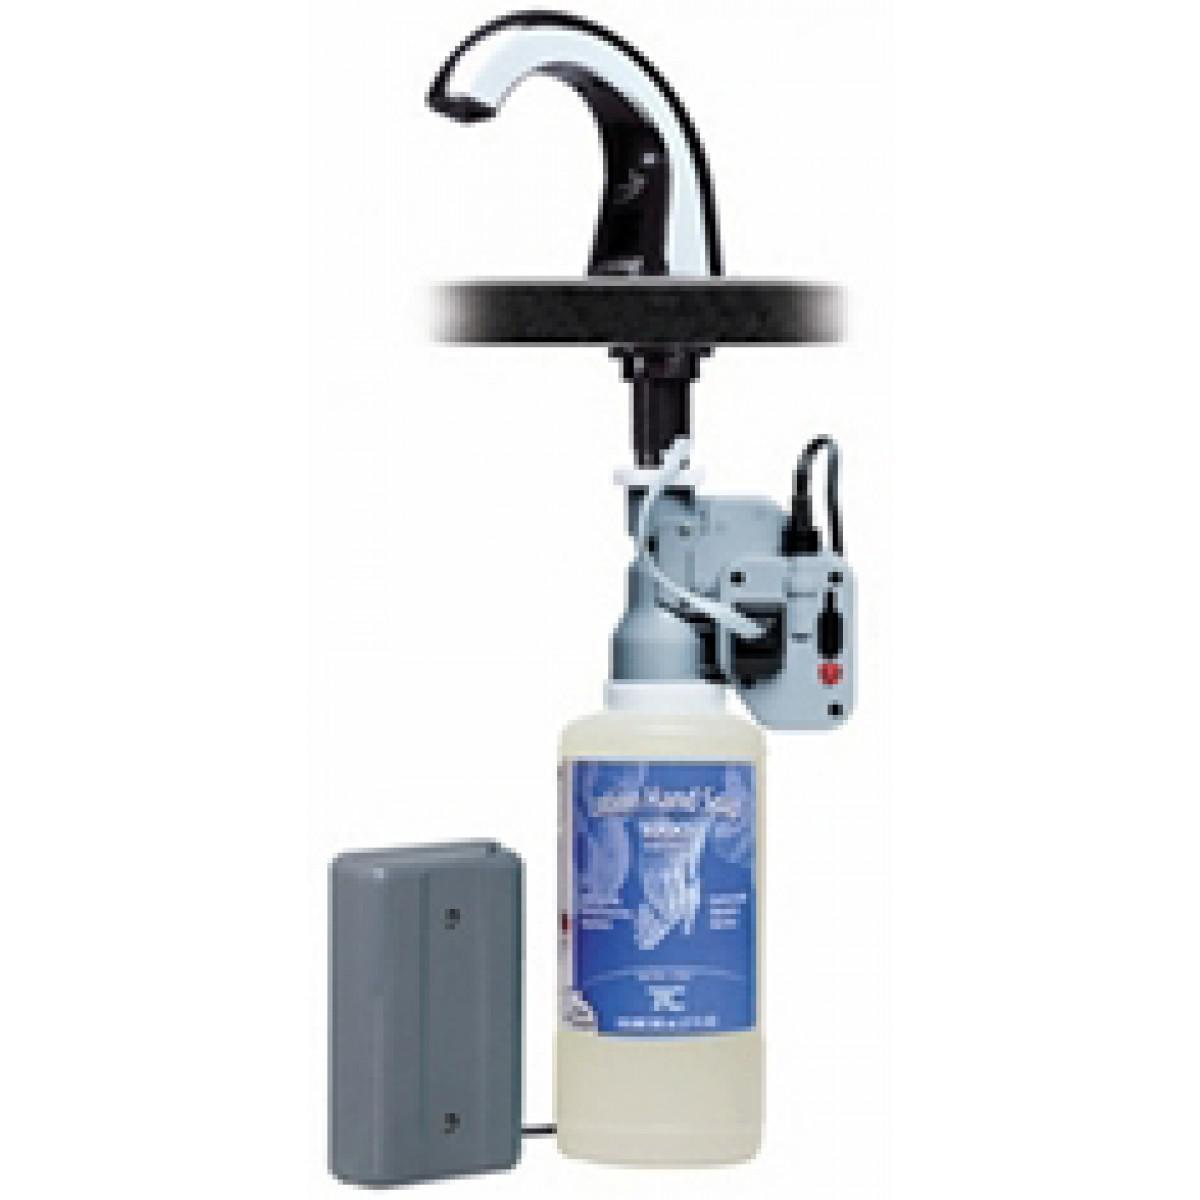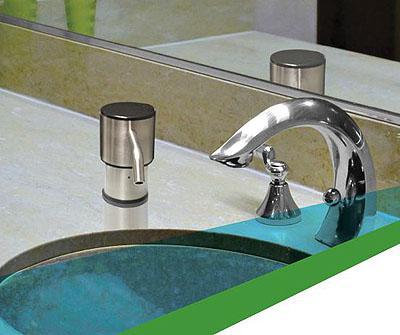The first image is the image on the left, the second image is the image on the right. For the images shown, is this caption "Right image includes one rounded sink with squirt-type dispenser nearby." true? Answer yes or no. Yes. 